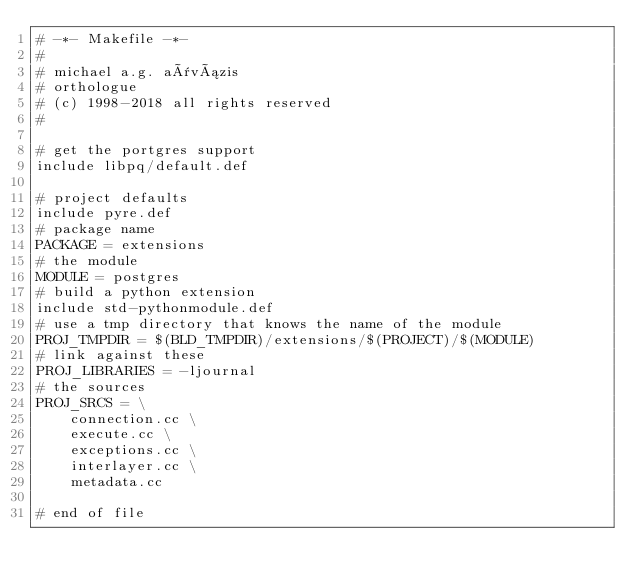Convert code to text. <code><loc_0><loc_0><loc_500><loc_500><_ObjectiveC_># -*- Makefile -*-
#
# michael a.g. aïvázis
# orthologue
# (c) 1998-2018 all rights reserved
#

# get the portgres support
include libpq/default.def

# project defaults
include pyre.def
# package name
PACKAGE = extensions
# the module
MODULE = postgres
# build a python extension
include std-pythonmodule.def
# use a tmp directory that knows the name of the module
PROJ_TMPDIR = $(BLD_TMPDIR)/extensions/$(PROJECT)/$(MODULE)
# link against these
PROJ_LIBRARIES = -ljournal
# the sources
PROJ_SRCS = \
    connection.cc \
    execute.cc \
    exceptions.cc \
    interlayer.cc \
    metadata.cc

# end of file
</code> 